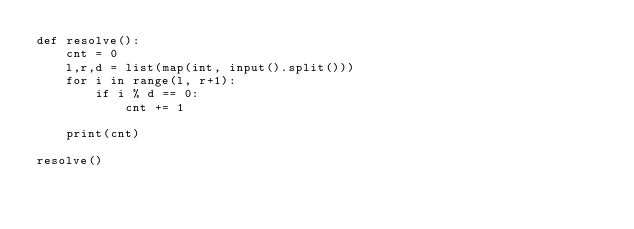Convert code to text. <code><loc_0><loc_0><loc_500><loc_500><_Python_>def resolve():
    cnt = 0
    l,r,d = list(map(int, input().split()))
    for i in range(l, r+1):
        if i % d == 0:
            cnt += 1
    
    print(cnt)
    
resolve()</code> 